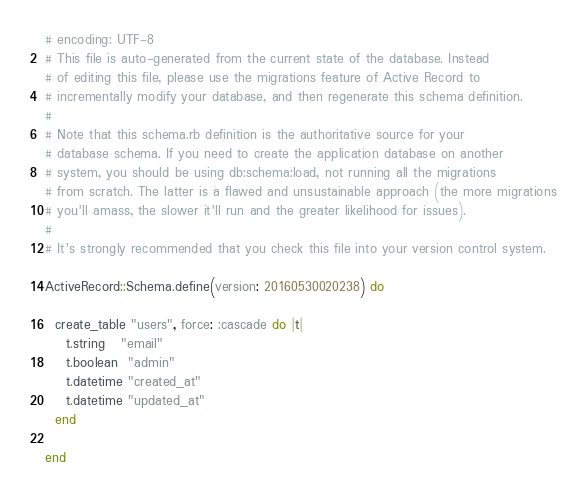Convert code to text. <code><loc_0><loc_0><loc_500><loc_500><_Ruby_># encoding: UTF-8
# This file is auto-generated from the current state of the database. Instead
# of editing this file, please use the migrations feature of Active Record to
# incrementally modify your database, and then regenerate this schema definition.
#
# Note that this schema.rb definition is the authoritative source for your
# database schema. If you need to create the application database on another
# system, you should be using db:schema:load, not running all the migrations
# from scratch. The latter is a flawed and unsustainable approach (the more migrations
# you'll amass, the slower it'll run and the greater likelihood for issues).
#
# It's strongly recommended that you check this file into your version control system.

ActiveRecord::Schema.define(version: 20160530020238) do

  create_table "users", force: :cascade do |t|
    t.string   "email"
    t.boolean  "admin"
    t.datetime "created_at"
    t.datetime "updated_at"
  end

end
</code> 